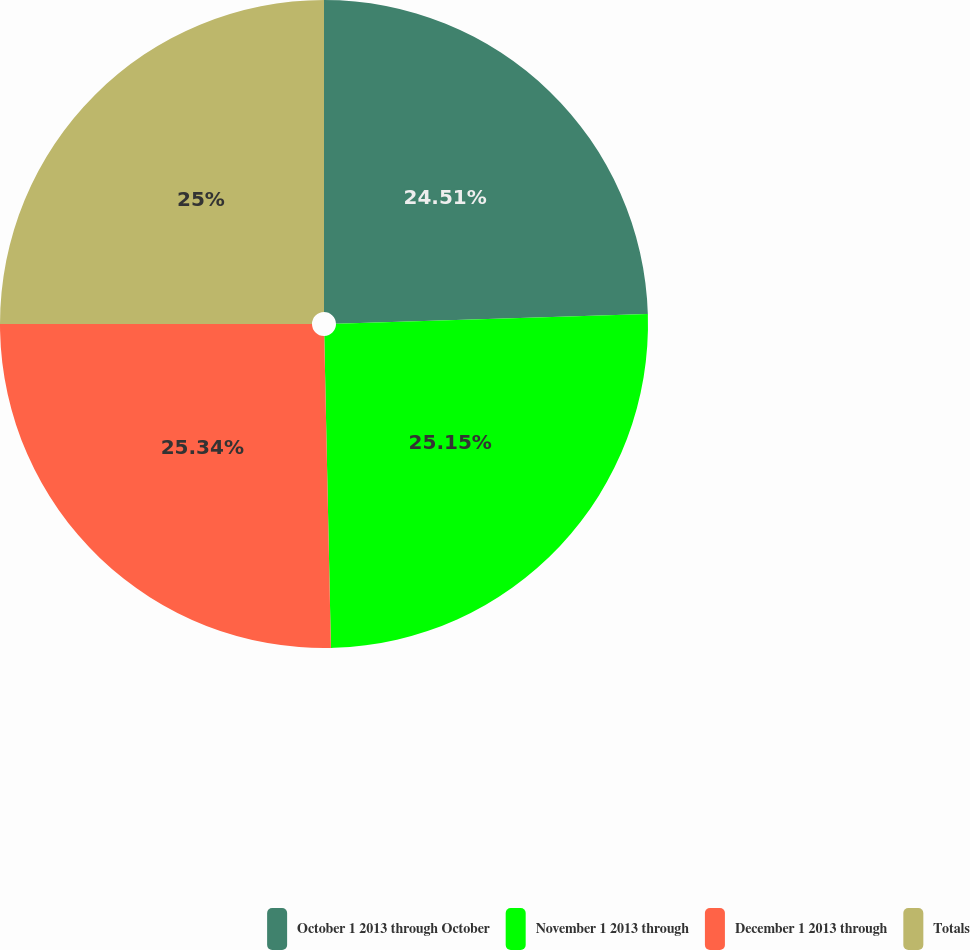<chart> <loc_0><loc_0><loc_500><loc_500><pie_chart><fcel>October 1 2013 through October<fcel>November 1 2013 through<fcel>December 1 2013 through<fcel>Totals<nl><fcel>24.51%<fcel>25.15%<fcel>25.34%<fcel>25.0%<nl></chart> 